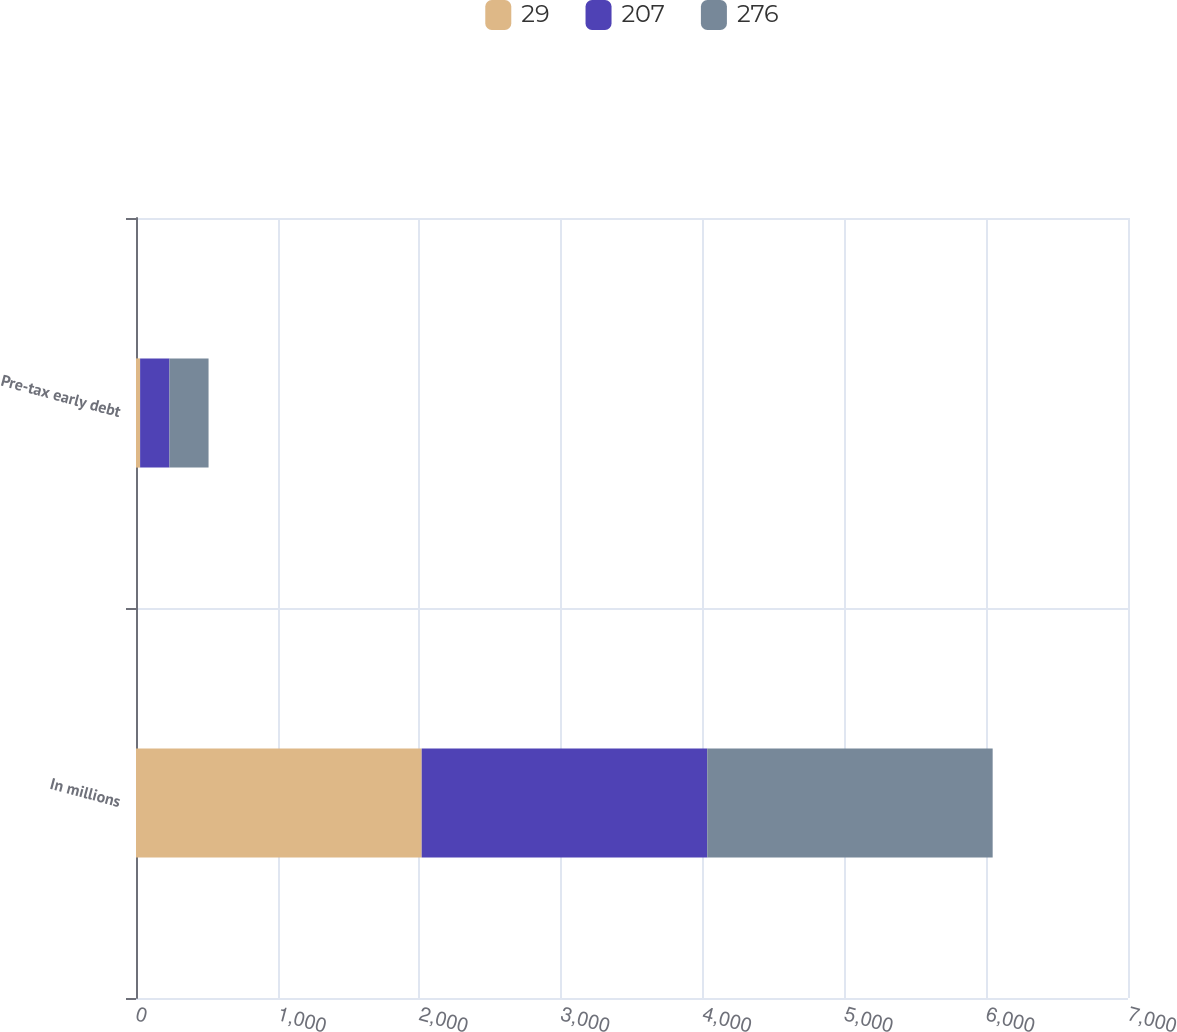Convert chart to OTSL. <chart><loc_0><loc_0><loc_500><loc_500><stacked_bar_chart><ecel><fcel>In millions<fcel>Pre-tax early debt<nl><fcel>29<fcel>2016<fcel>29<nl><fcel>207<fcel>2015<fcel>207<nl><fcel>276<fcel>2014<fcel>276<nl></chart> 